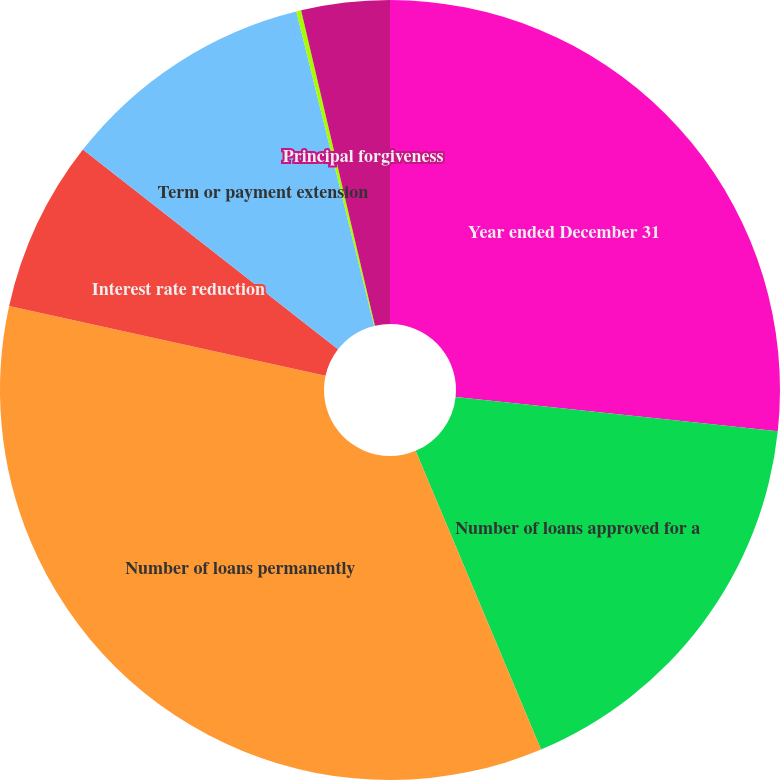Convert chart to OTSL. <chart><loc_0><loc_0><loc_500><loc_500><pie_chart><fcel>Year ended December 31<fcel>Number of loans approved for a<fcel>Number of loans permanently<fcel>Interest rate reduction<fcel>Term or payment extension<fcel>Principal and/or interest<fcel>Principal forgiveness<nl><fcel>26.69%<fcel>16.98%<fcel>34.78%<fcel>7.12%<fcel>10.57%<fcel>0.2%<fcel>3.66%<nl></chart> 